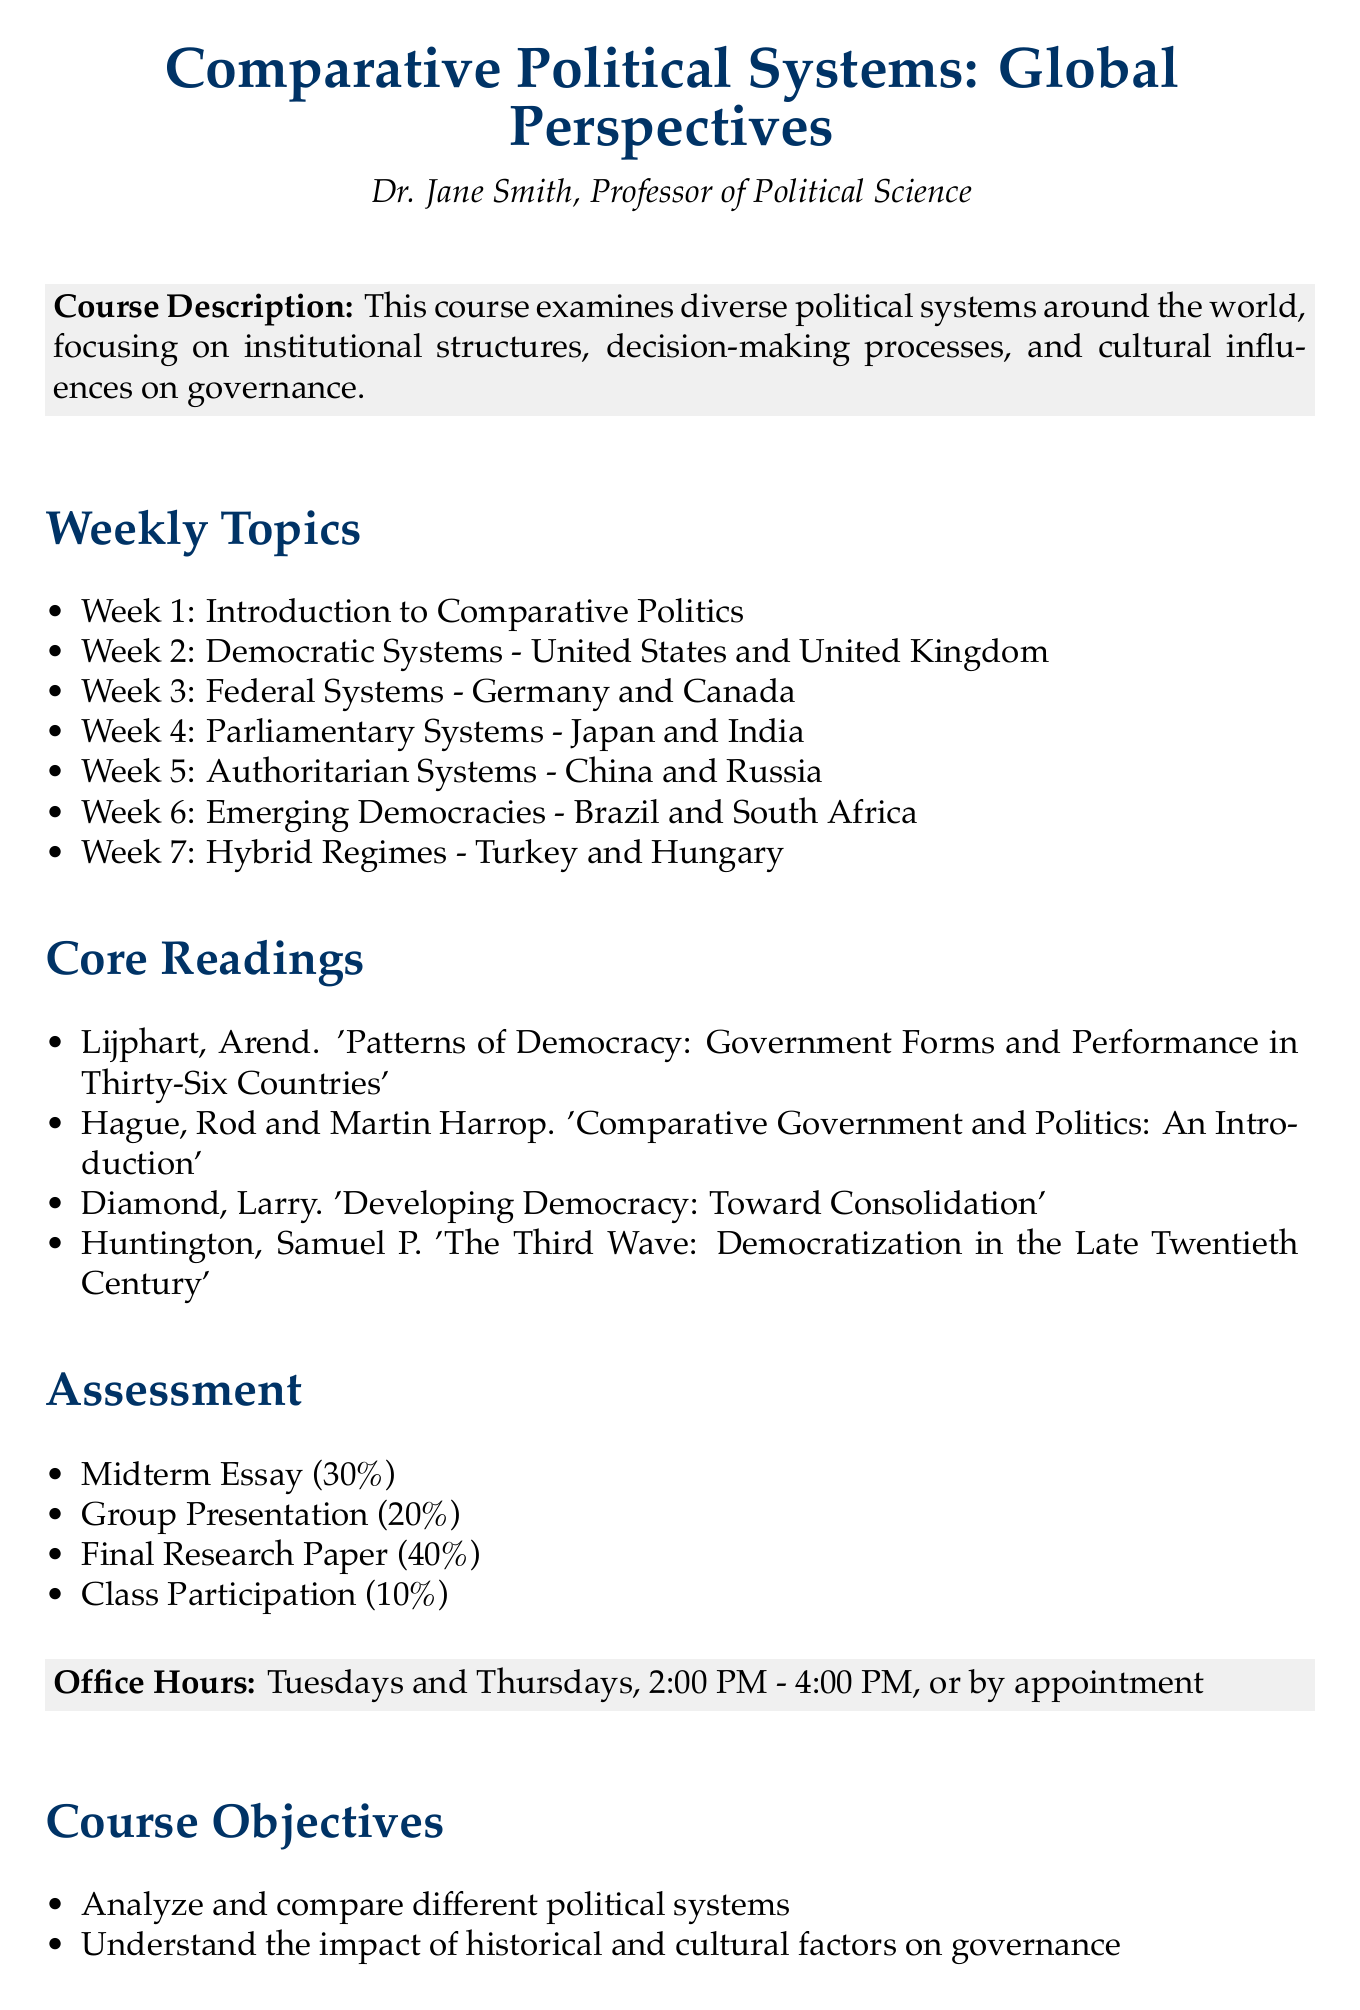What is the course title? The course title is found in the header section of the document which indicates the main focus of the syllabus.
Answer: Comparative Political Systems: Global Perspectives Who is the professor of the course? The professor's name is provided at the beginning of the syllabus under the title, specifying the instructor.
Answer: Dr. Jane Smith How many weeks are covered in the course? The number of weeks can be gathered from the list of weekly topics provided in the document.
Answer: 7 What percentage is allocated to the Final Research Paper? This percentage is listed under the assessment section of the document, detailing the grading components.
Answer: 40% Which countries are discussed in relation to Authoritarian Systems? The countries are mentioned under the weekly topics, illustrating key areas of focus in that week.
Answer: China and Russia What is one of the course objectives? Course objectives are listed and provide insight into the goals of the course, indicating expectations from students.
Answer: Analyze and compare different political systems What is the book by Arend Lijphart? This book can be identified in the core readings section, showcasing required literature for the course.
Answer: Patterns of Democracy: Government Forms and Performance in Thirty-Six Countries On which days are office hours held? This information is noted in the course details, specifying the availability of the professor for student meetings.
Answer: Tuesdays and Thursdays 